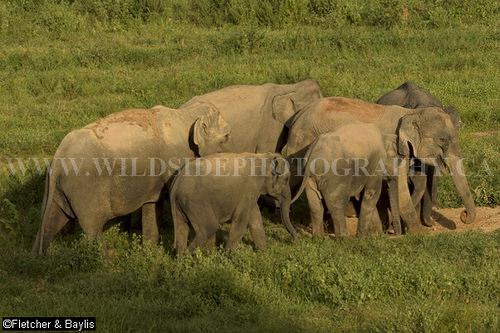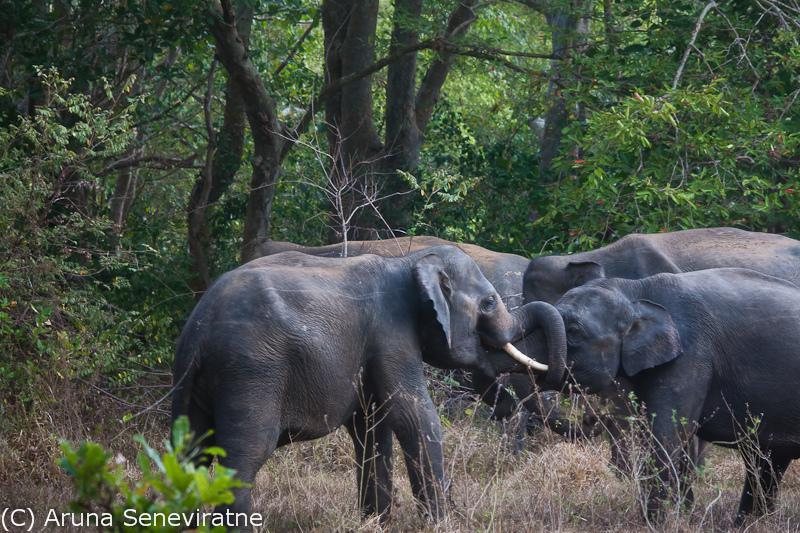The first image is the image on the left, the second image is the image on the right. Assess this claim about the two images: "There is exactly one animal in the image on the right.". Correct or not? Answer yes or no. No. 